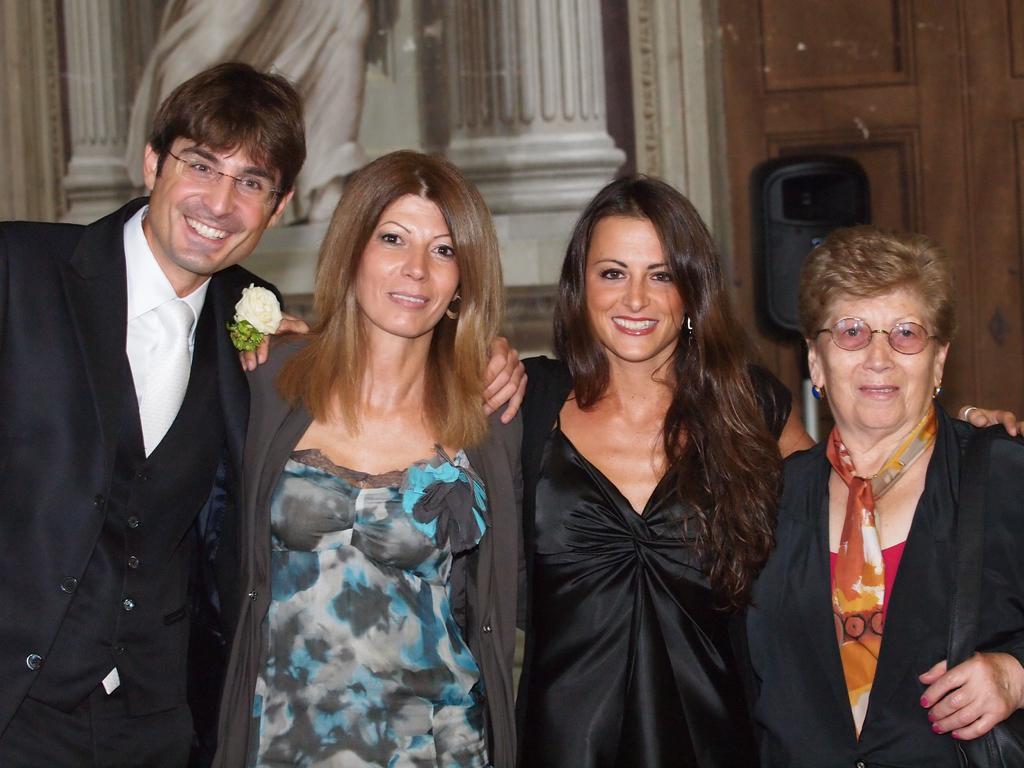In one or two sentences, can you explain what this image depicts? In this picture we can see four people smiling, standing and in the background we can see doors, some objects. 